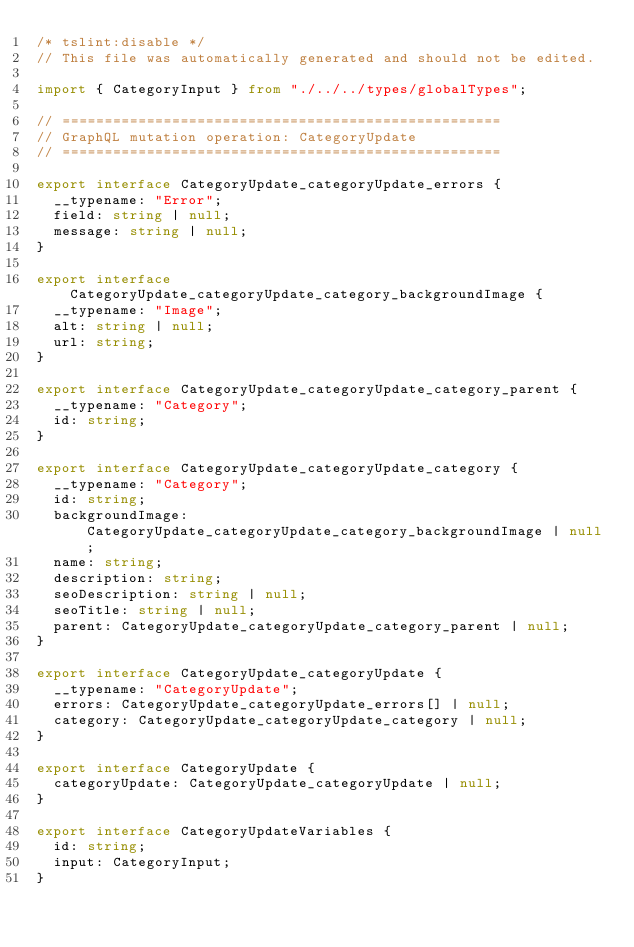Convert code to text. <code><loc_0><loc_0><loc_500><loc_500><_TypeScript_>/* tslint:disable */
// This file was automatically generated and should not be edited.

import { CategoryInput } from "./../../types/globalTypes";

// ====================================================
// GraphQL mutation operation: CategoryUpdate
// ====================================================

export interface CategoryUpdate_categoryUpdate_errors {
  __typename: "Error";
  field: string | null;
  message: string | null;
}

export interface CategoryUpdate_categoryUpdate_category_backgroundImage {
  __typename: "Image";
  alt: string | null;
  url: string;
}

export interface CategoryUpdate_categoryUpdate_category_parent {
  __typename: "Category";
  id: string;
}

export interface CategoryUpdate_categoryUpdate_category {
  __typename: "Category";
  id: string;
  backgroundImage: CategoryUpdate_categoryUpdate_category_backgroundImage | null;
  name: string;
  description: string;
  seoDescription: string | null;
  seoTitle: string | null;
  parent: CategoryUpdate_categoryUpdate_category_parent | null;
}

export interface CategoryUpdate_categoryUpdate {
  __typename: "CategoryUpdate";
  errors: CategoryUpdate_categoryUpdate_errors[] | null;
  category: CategoryUpdate_categoryUpdate_category | null;
}

export interface CategoryUpdate {
  categoryUpdate: CategoryUpdate_categoryUpdate | null;
}

export interface CategoryUpdateVariables {
  id: string;
  input: CategoryInput;
}
</code> 